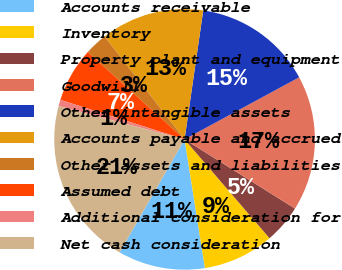<chart> <loc_0><loc_0><loc_500><loc_500><pie_chart><fcel>Accounts receivable<fcel>Inventory<fcel>Property plant and equipment<fcel>Goodwill<fcel>Other intangible assets<fcel>Accounts payable and accrued<fcel>Other assets and liabilities<fcel>Assumed debt<fcel>Additional consideration for<fcel>Net cash consideration<nl><fcel>10.8%<fcel>8.8%<fcel>4.79%<fcel>16.81%<fcel>14.81%<fcel>12.81%<fcel>2.79%<fcel>6.79%<fcel>0.78%<fcel>20.82%<nl></chart> 